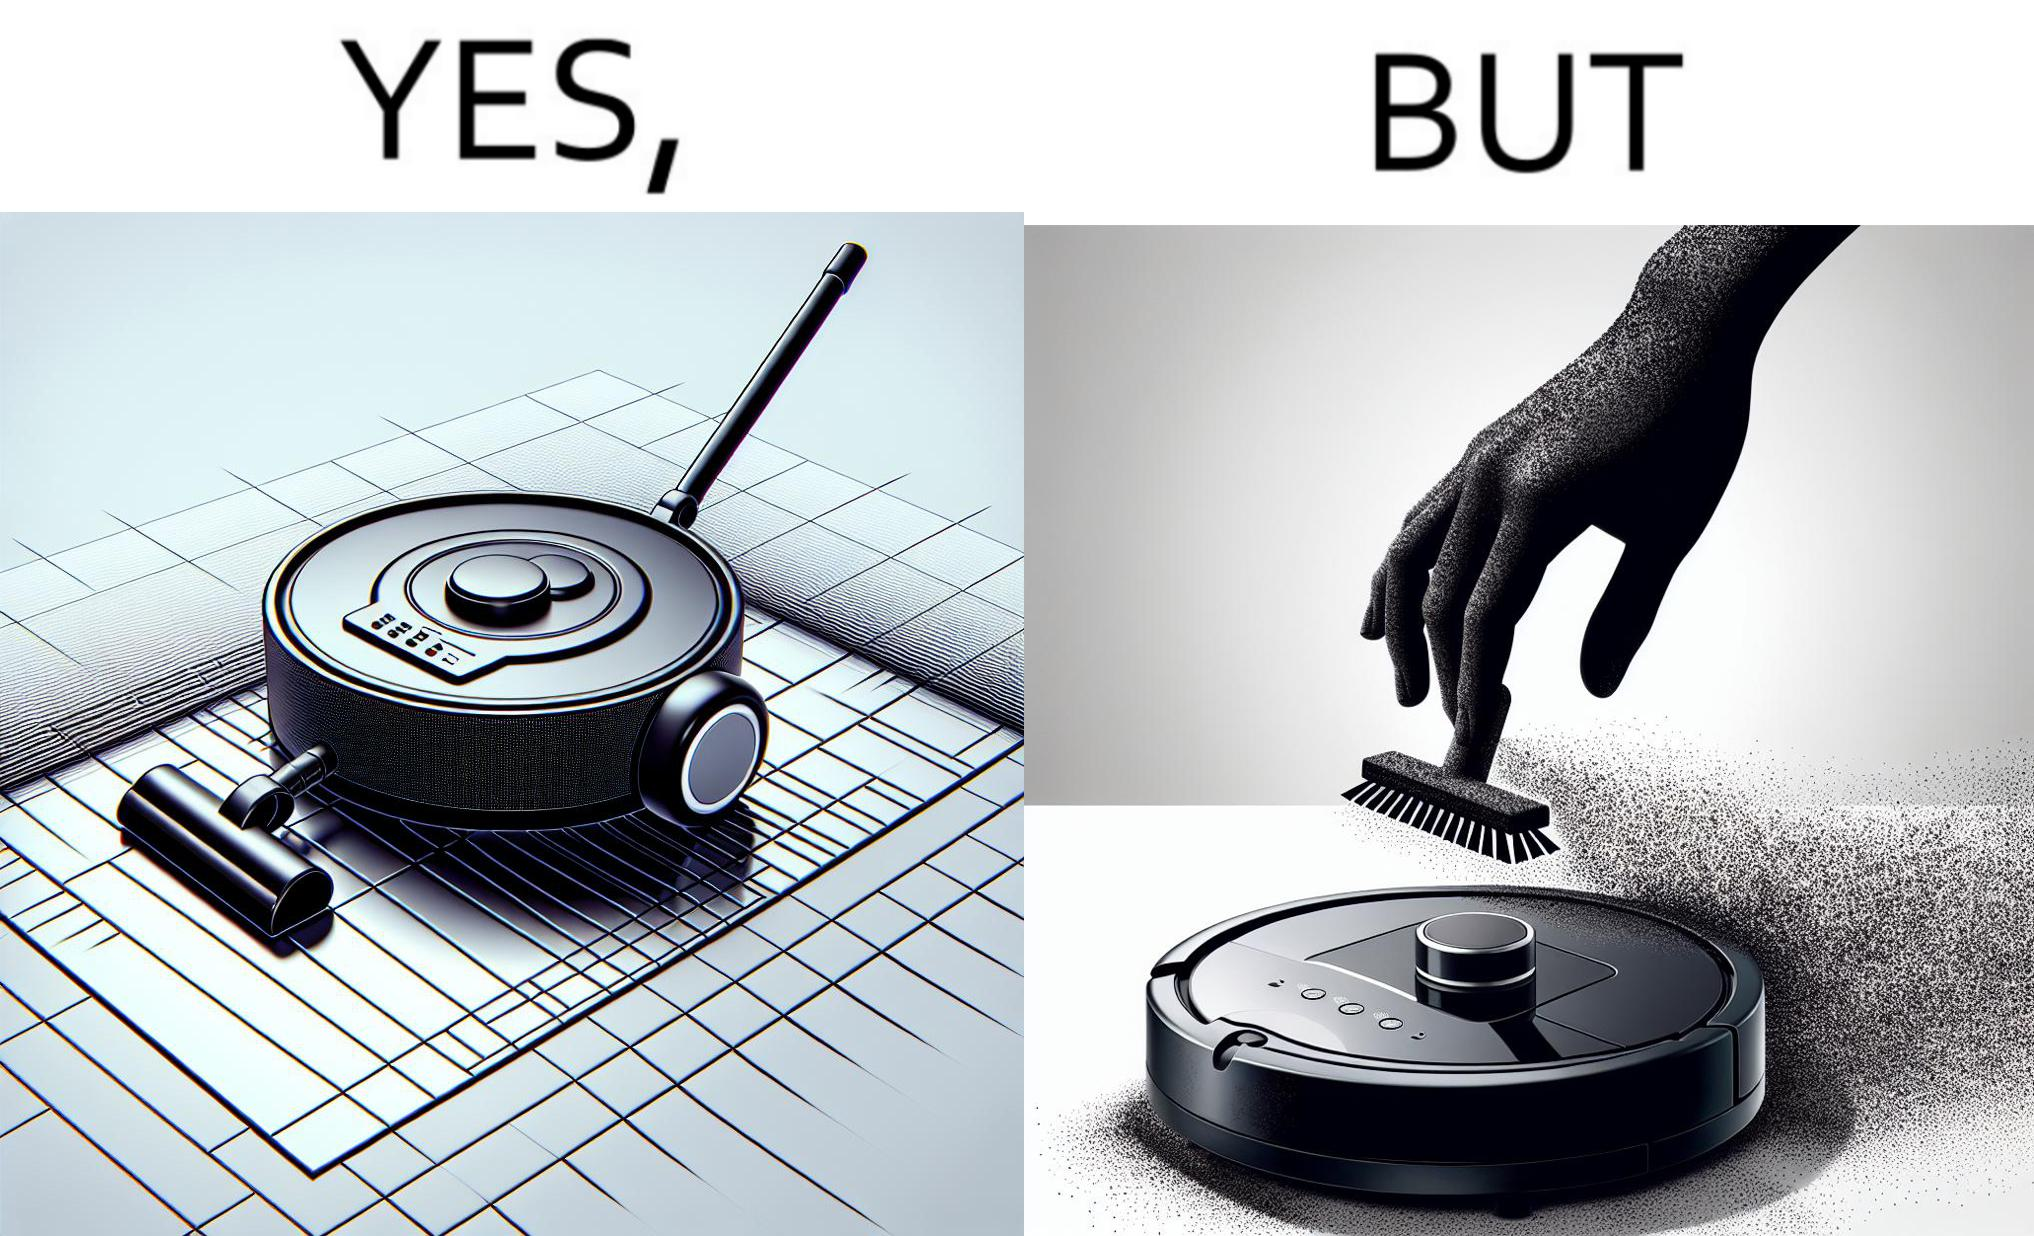Is this image satirical or non-satirical? Yes, this image is satirical. 